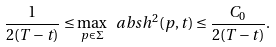<formula> <loc_0><loc_0><loc_500><loc_500>\frac { 1 } { 2 ( T - t ) } \leq \max _ { p \in \Sigma } \ a b s { h } ^ { 2 } ( p , t ) \leq \frac { C _ { 0 } } { 2 ( T - t ) } .</formula> 